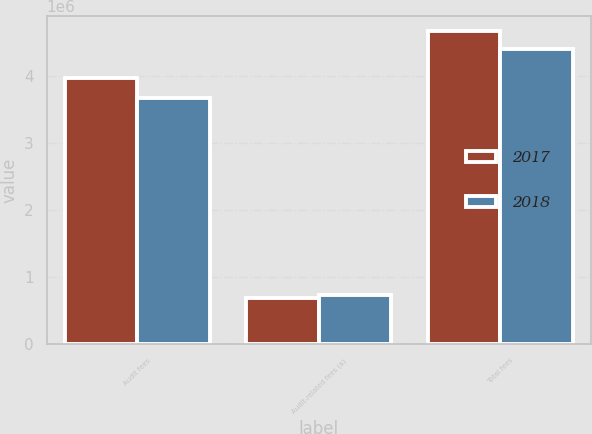<chart> <loc_0><loc_0><loc_500><loc_500><stacked_bar_chart><ecel><fcel>Audit fees<fcel>Audit-related fees (a)<fcel>Total fees<nl><fcel>2017<fcel>3.97009e+06<fcel>693930<fcel>4.66402e+06<nl><fcel>2018<fcel>3.66479e+06<fcel>739834<fcel>4.40463e+06<nl></chart> 